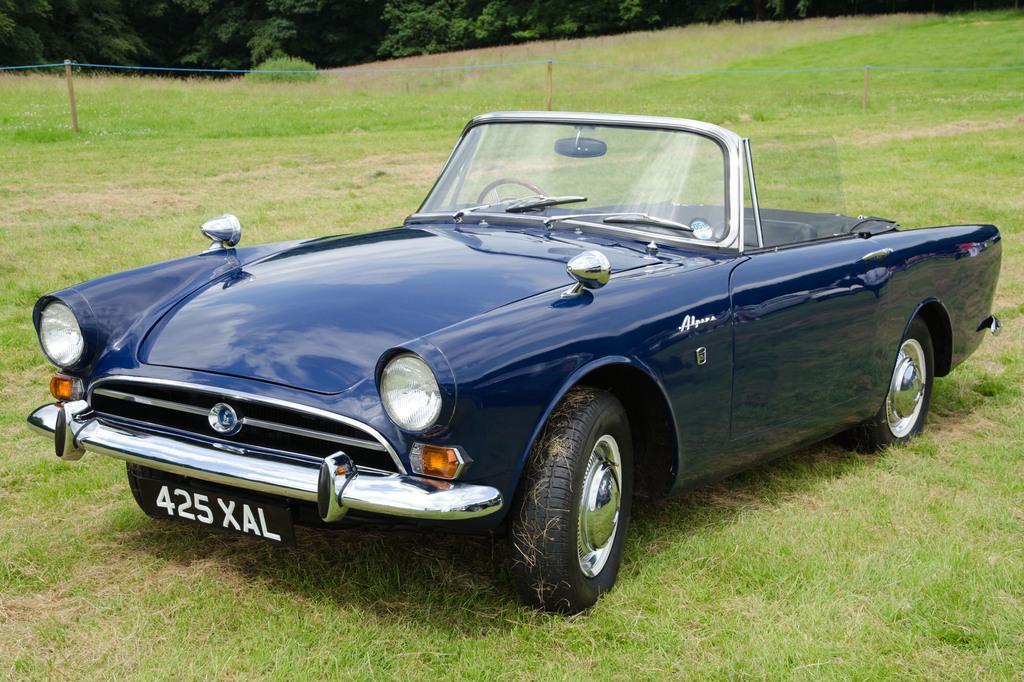In one or two sentences, can you explain what this image depicts? In the image there is a black car on a grass field, on the background there are trees all over the image. 